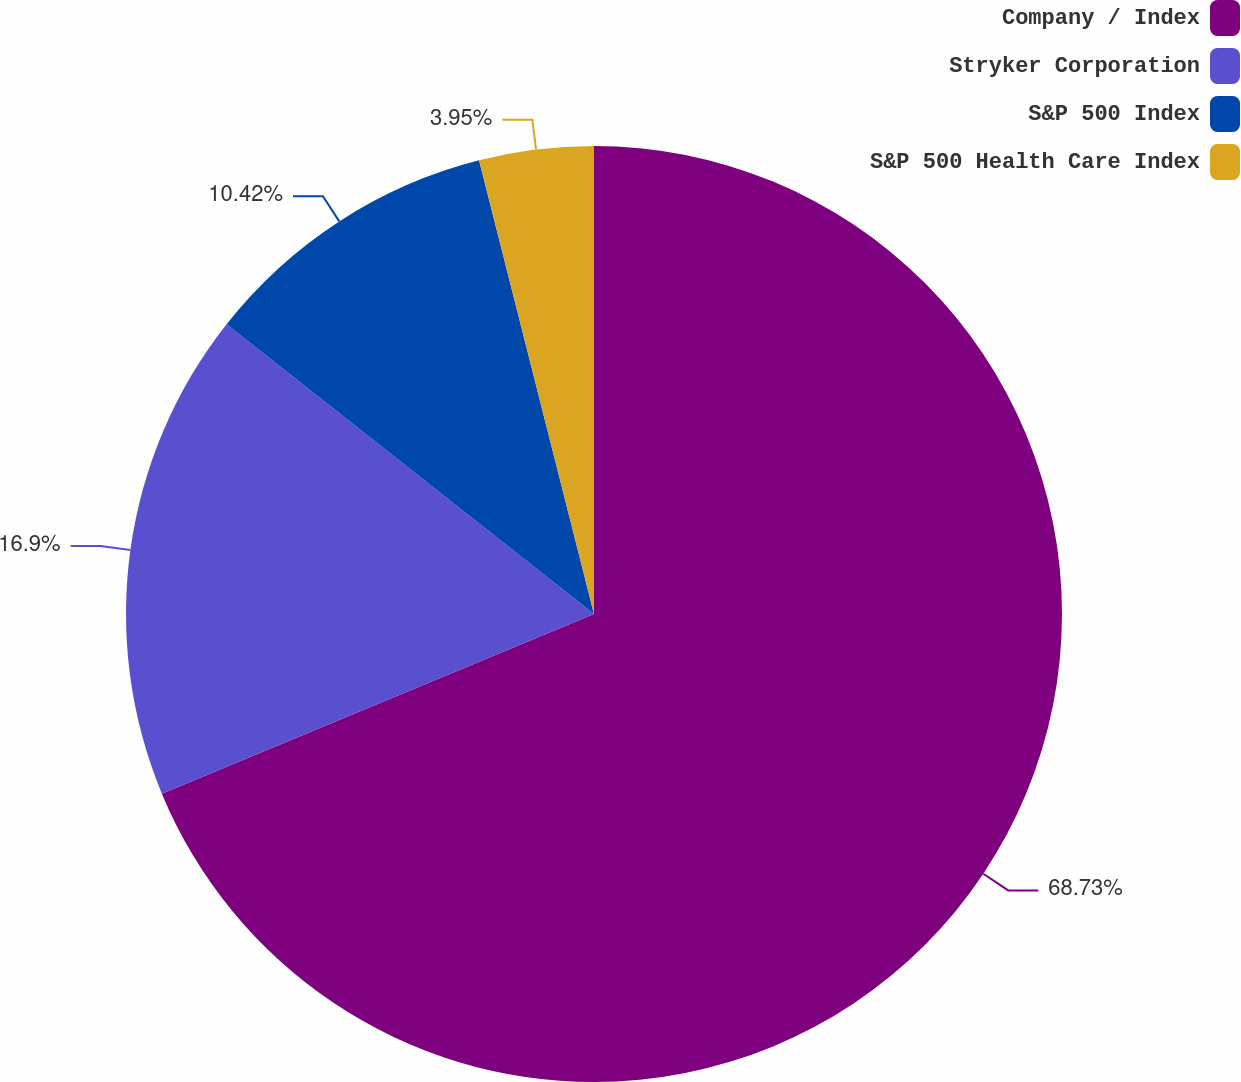<chart> <loc_0><loc_0><loc_500><loc_500><pie_chart><fcel>Company / Index<fcel>Stryker Corporation<fcel>S&P 500 Index<fcel>S&P 500 Health Care Index<nl><fcel>68.73%<fcel>16.9%<fcel>10.42%<fcel>3.95%<nl></chart> 